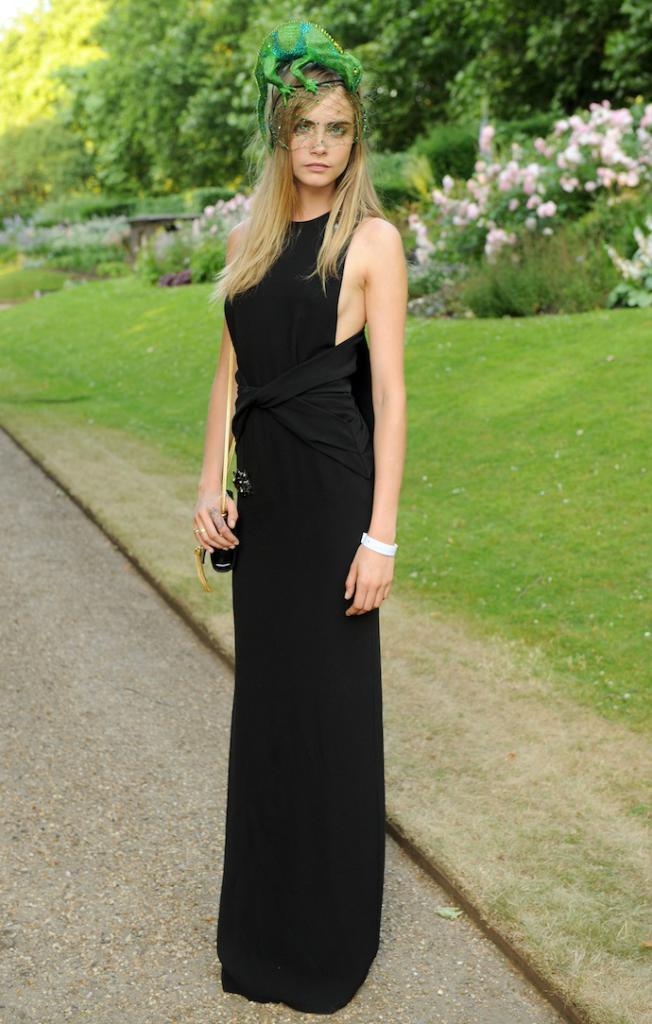Who is present in the image? There is a lady in the image. What is the lady wearing on her body? The lady is wearing a bag. What is on the lady's head? There is a green color animal on the lady's head. What can be seen in the background of the image? There is grass, flowering plants, and trees in the background of the image. Can you tell me how much honey the lady is carrying in her pocket? There is no mention of honey or a pocket in the image, so it cannot be determined. 